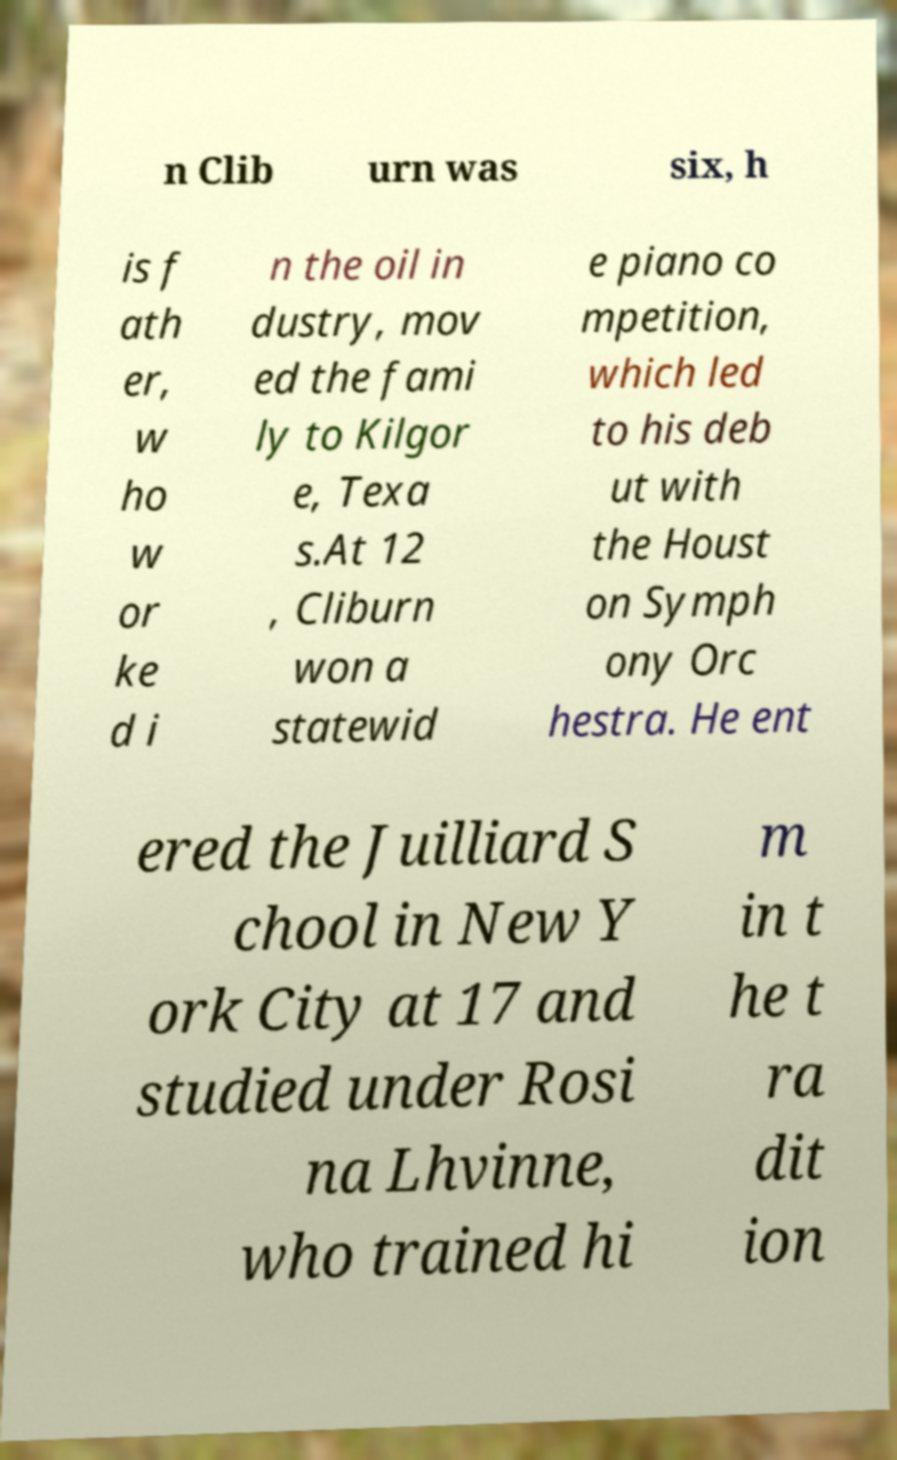I need the written content from this picture converted into text. Can you do that? n Clib urn was six, h is f ath er, w ho w or ke d i n the oil in dustry, mov ed the fami ly to Kilgor e, Texa s.At 12 , Cliburn won a statewid e piano co mpetition, which led to his deb ut with the Houst on Symph ony Orc hestra. He ent ered the Juilliard S chool in New Y ork City at 17 and studied under Rosi na Lhvinne, who trained hi m in t he t ra dit ion 